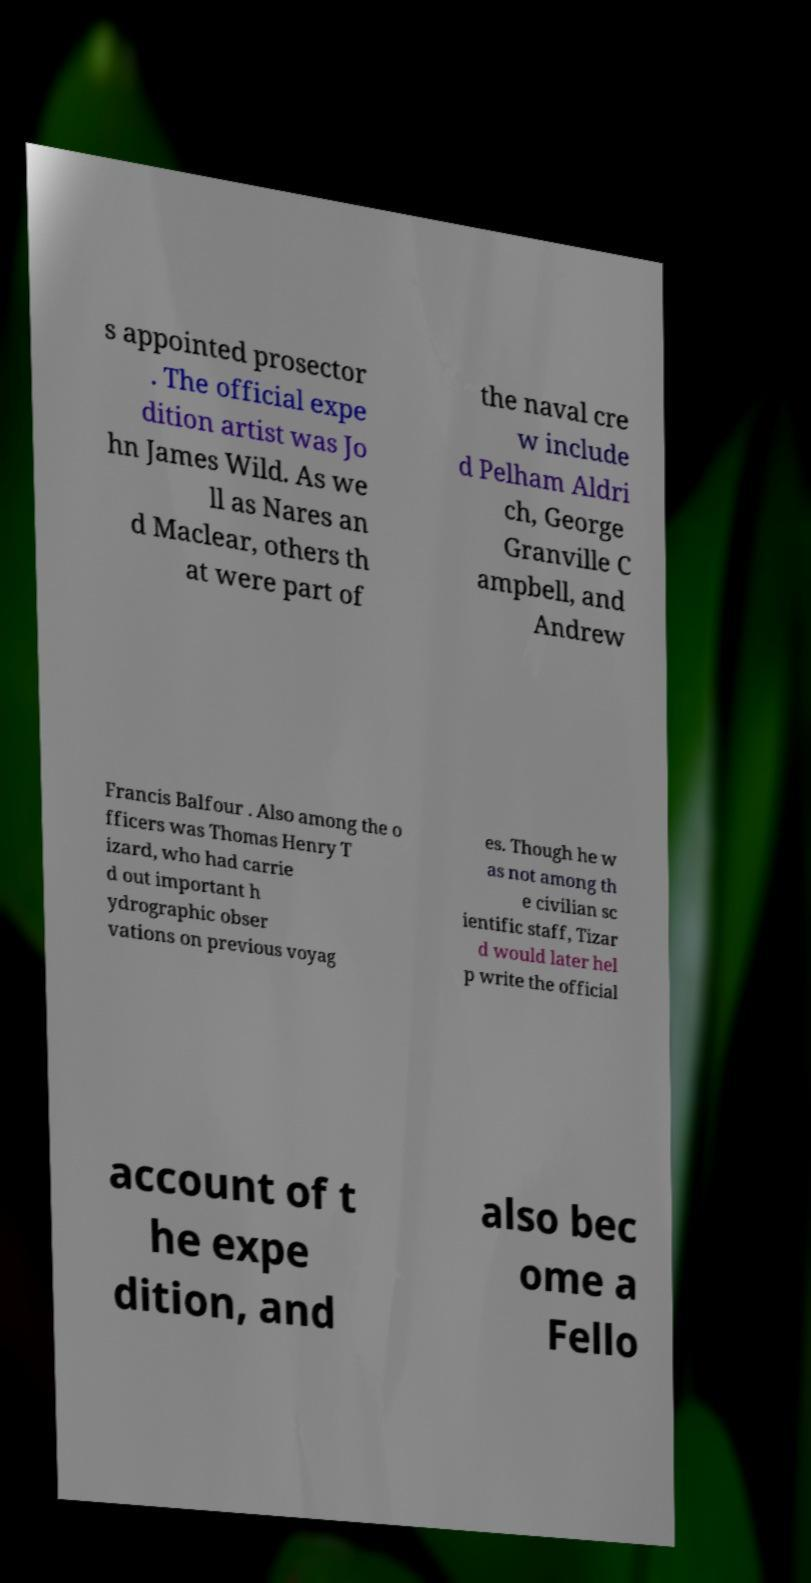Can you read and provide the text displayed in the image?This photo seems to have some interesting text. Can you extract and type it out for me? s appointed prosector . The official expe dition artist was Jo hn James Wild. As we ll as Nares an d Maclear, others th at were part of the naval cre w include d Pelham Aldri ch, George Granville C ampbell, and Andrew Francis Balfour . Also among the o fficers was Thomas Henry T izard, who had carrie d out important h ydrographic obser vations on previous voyag es. Though he w as not among th e civilian sc ientific staff, Tizar d would later hel p write the official account of t he expe dition, and also bec ome a Fello 